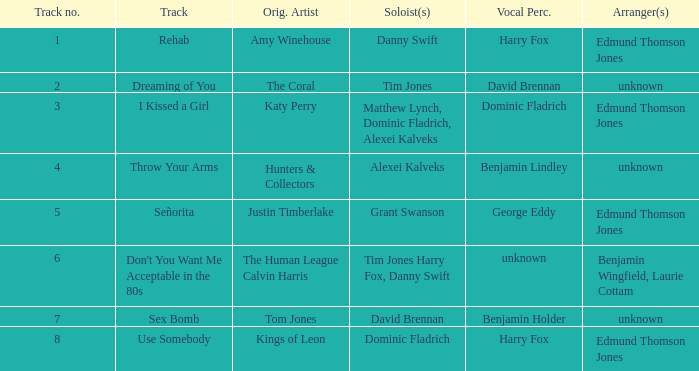Who is the artist where the vocal percussionist is Benjamin Holder? Tom Jones. 